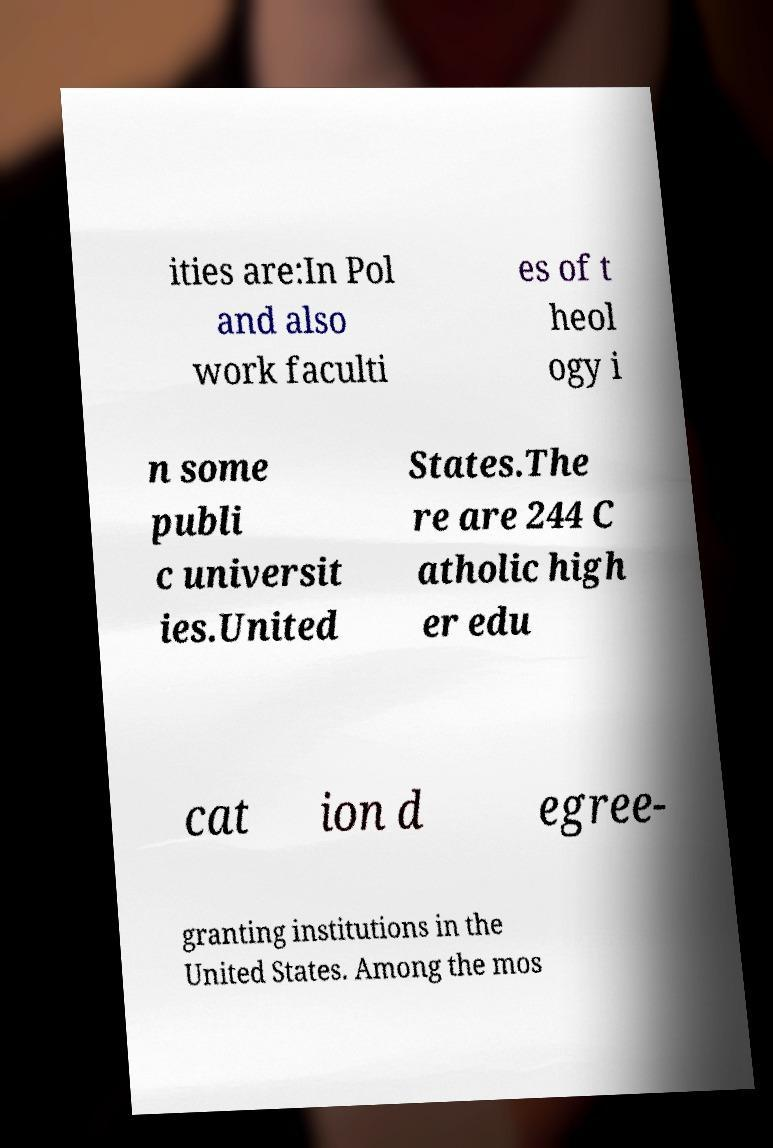Can you accurately transcribe the text from the provided image for me? ities are:In Pol and also work faculti es of t heol ogy i n some publi c universit ies.United States.The re are 244 C atholic high er edu cat ion d egree- granting institutions in the United States. Among the mos 